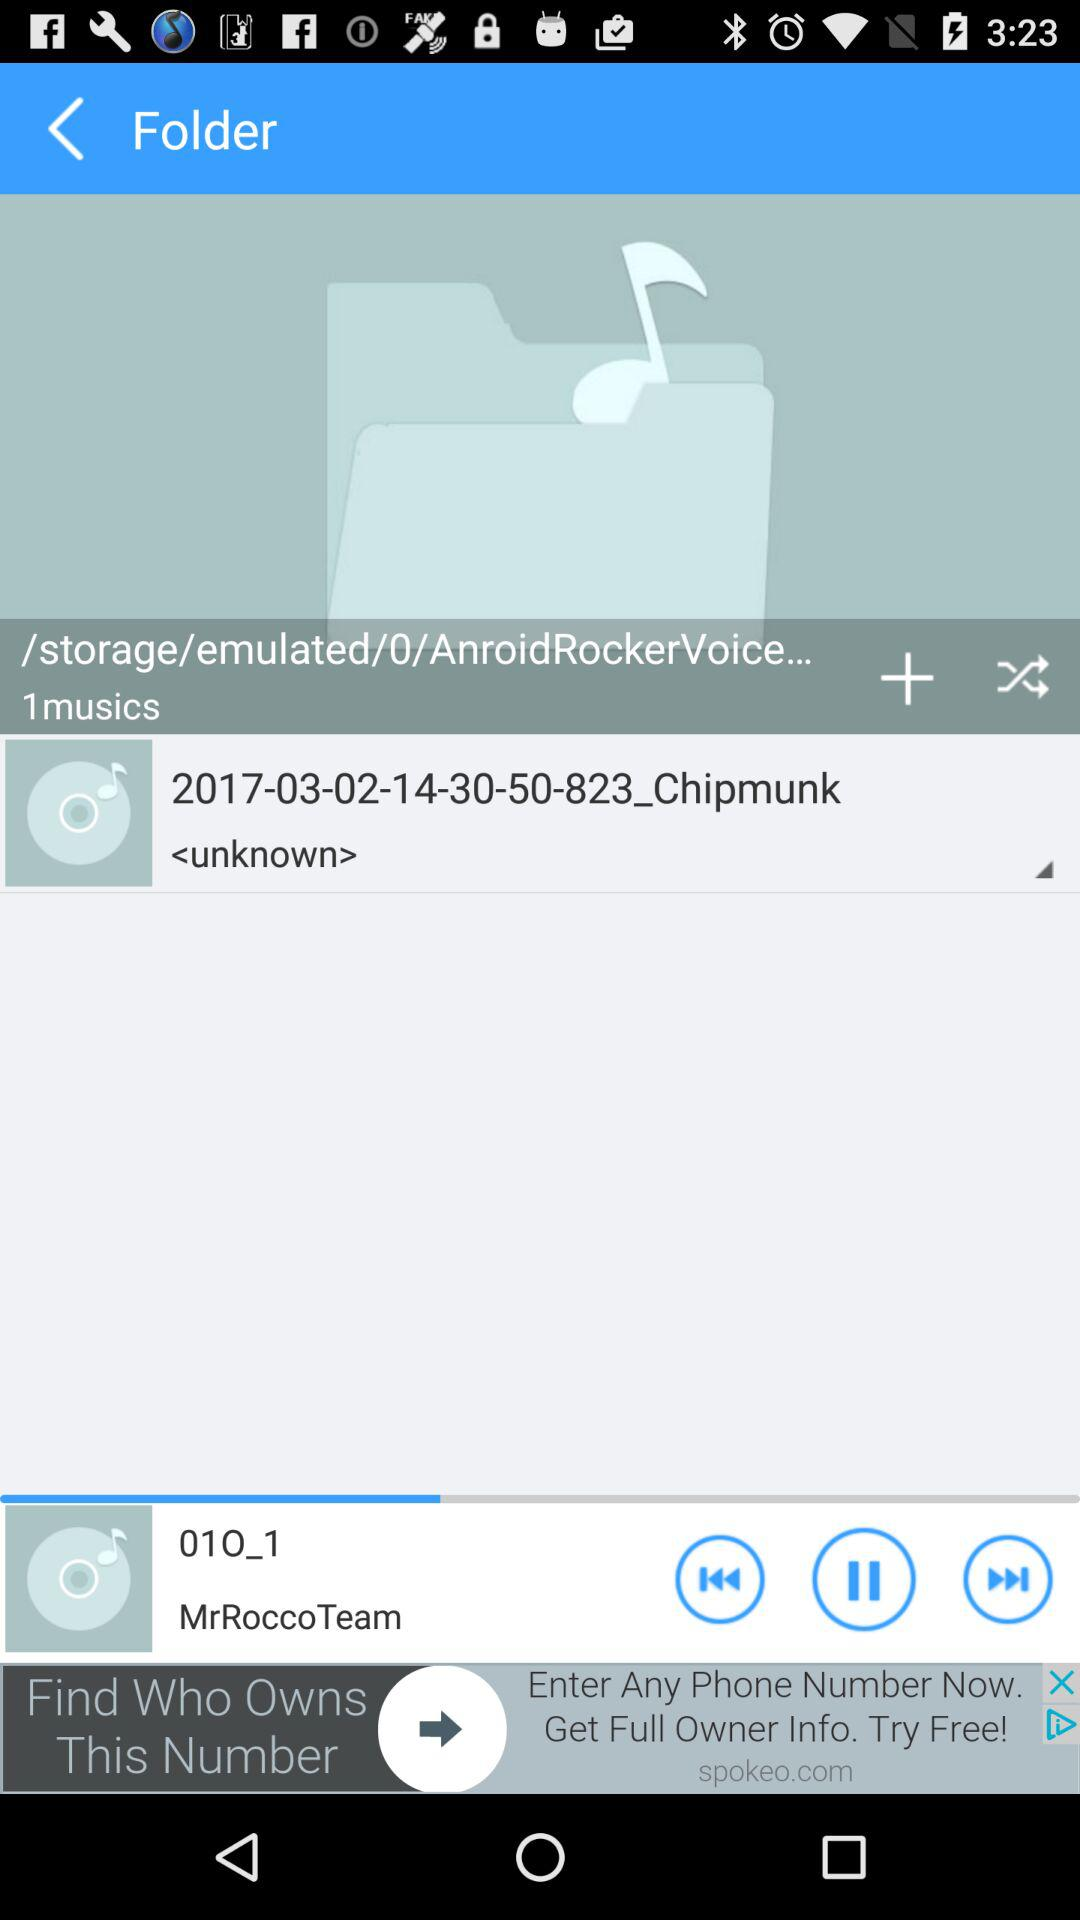How many musics are in the current folder?
Answer the question using a single word or phrase. 1 